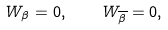<formula> <loc_0><loc_0><loc_500><loc_500>W _ { \beta } = 0 , \quad W _ { \overline { \beta } } = 0 ,</formula> 